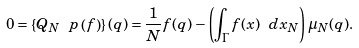Convert formula to latex. <formula><loc_0><loc_0><loc_500><loc_500>0 = \left \{ Q _ { N } \ p \left ( f \right ) \right \} ( q ) = \frac { 1 } { N } f ( q ) - \left ( \int _ { \Gamma } f ( x ) \ d x _ { N } \right ) \mu _ { N } ( q ) .</formula> 